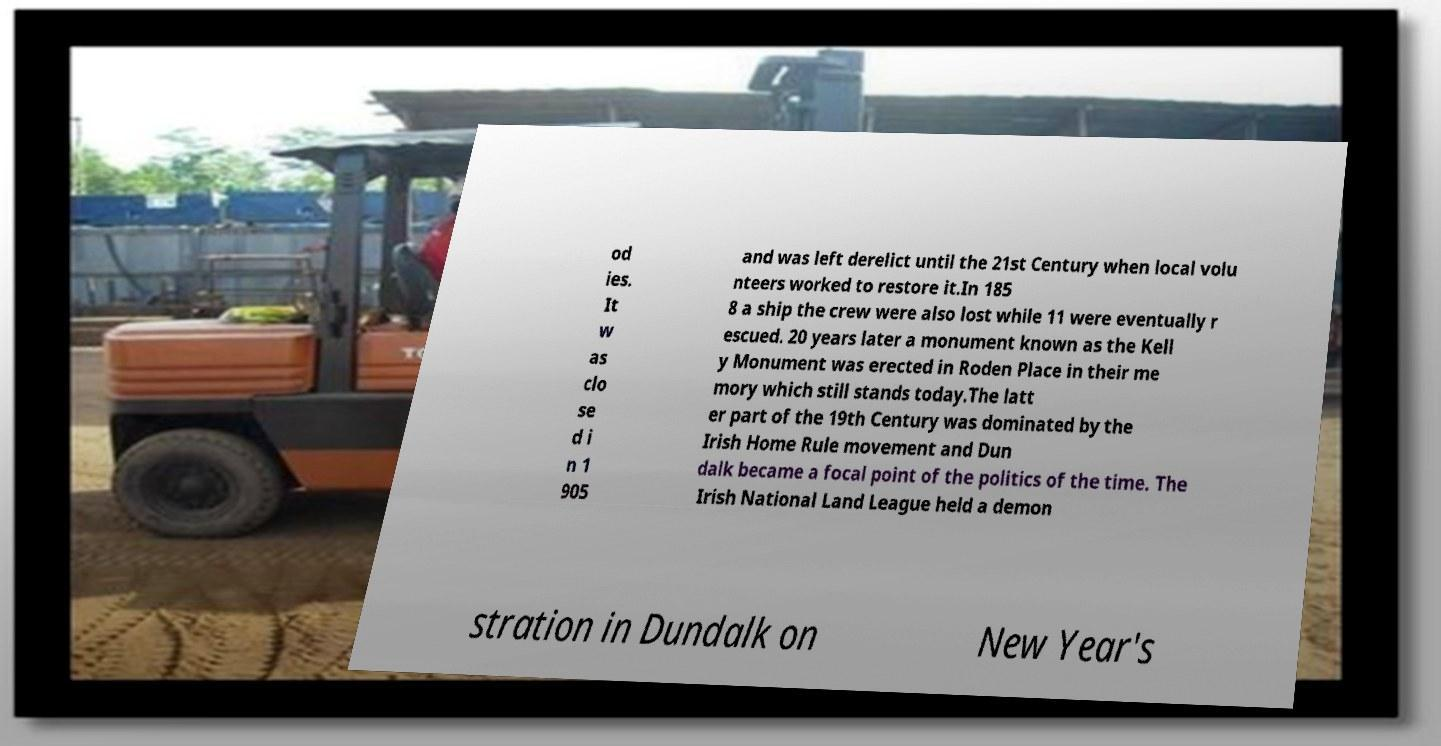Please read and relay the text visible in this image. What does it say? od ies. It w as clo se d i n 1 905 and was left derelict until the 21st Century when local volu nteers worked to restore it.In 185 8 a ship the crew were also lost while 11 were eventually r escued. 20 years later a monument known as the Kell y Monument was erected in Roden Place in their me mory which still stands today.The latt er part of the 19th Century was dominated by the Irish Home Rule movement and Dun dalk became a focal point of the politics of the time. The Irish National Land League held a demon stration in Dundalk on New Year's 